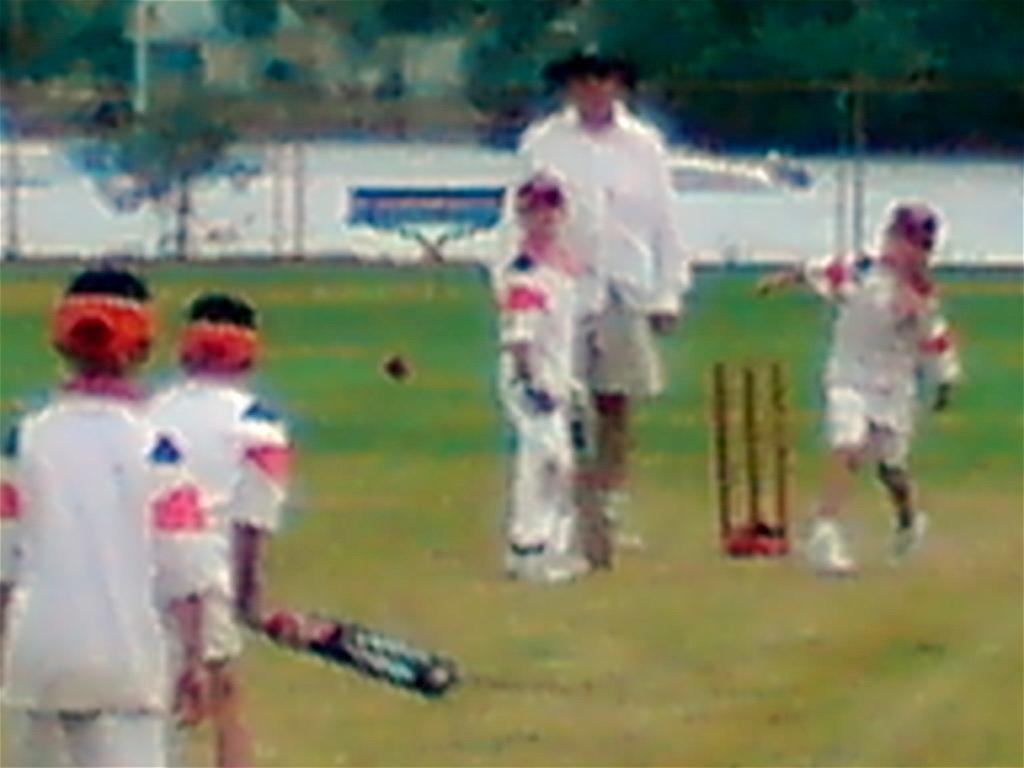Can you describe this image briefly? In this picture I can see four boys who are playing the cricket. Beside the bowler there is an umpire who is standing near to the wickets. In the back I can see the ground, wall, trees, plants and grass. In the top left corner I can see the blur image. 